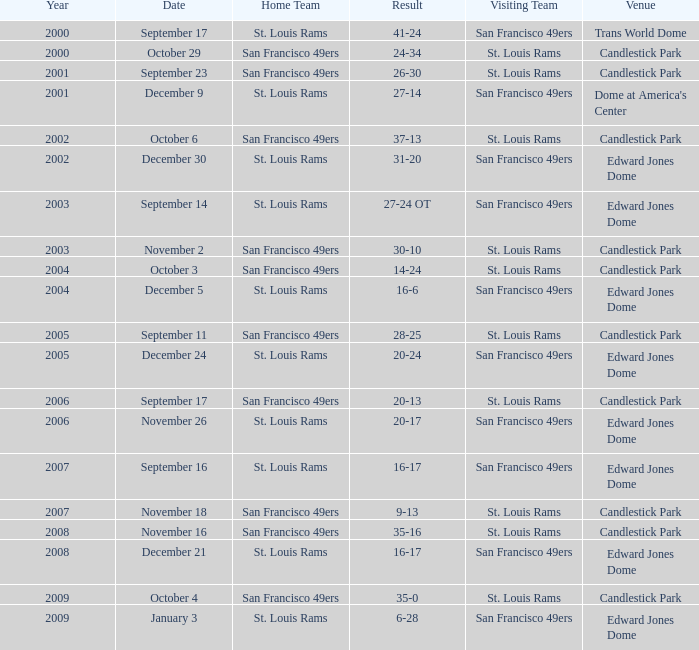On november 26, what was the location of the event? Edward Jones Dome. 